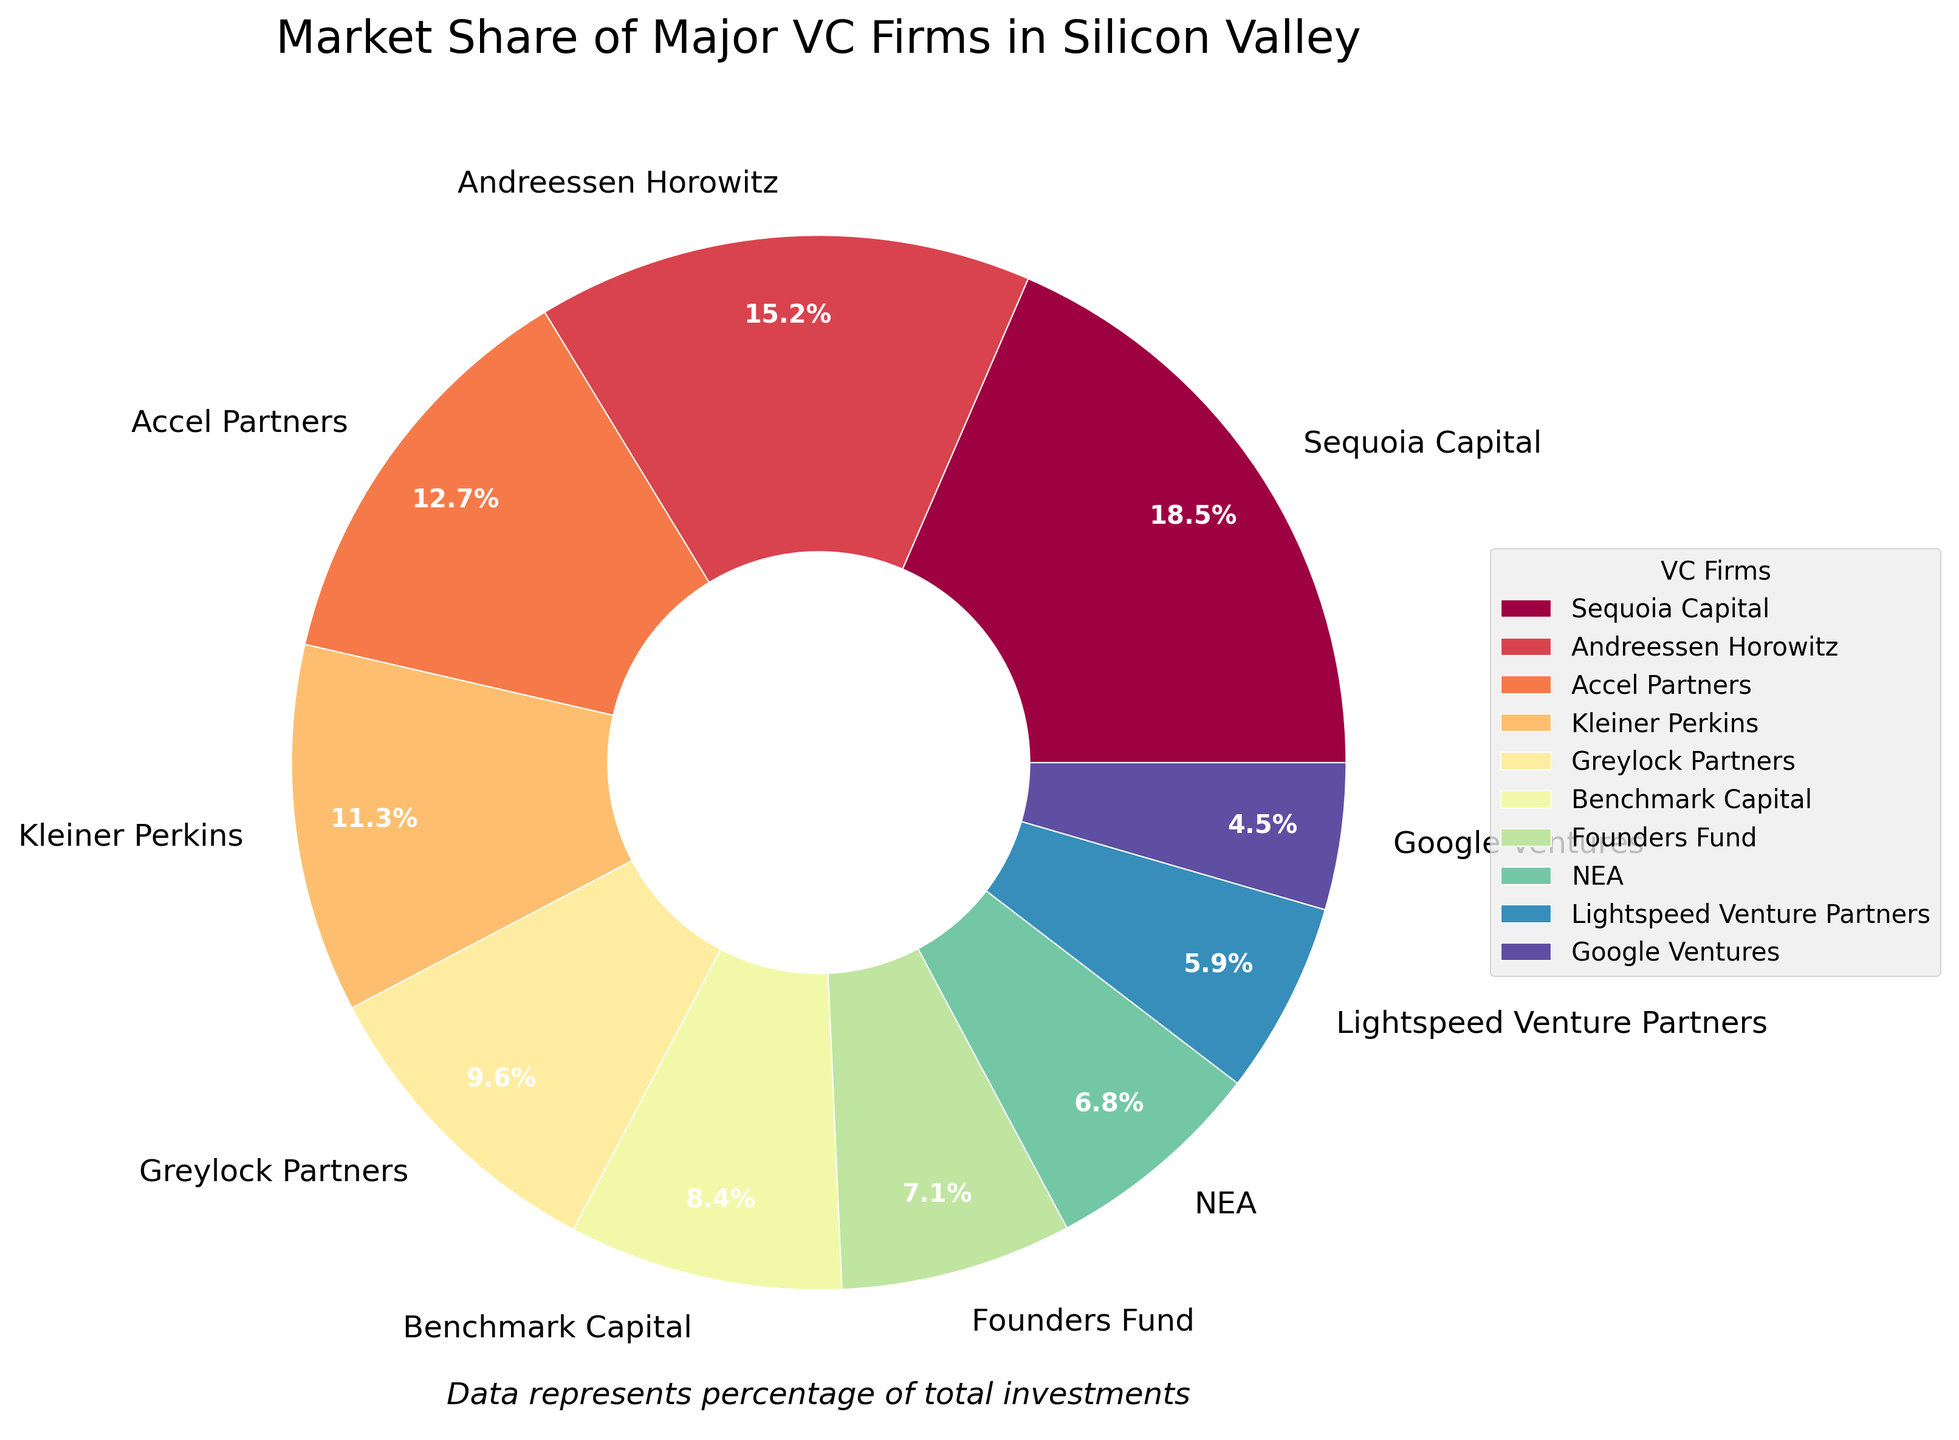What's the largest market share among the venture capital firms? Look at the figure and identify the firm with the largest section in the pie chart. The largest segment is labeled "Sequoia Capital" with 18.5%.
Answer: Sequoia Capital Which two firms have a combined market share of more than 30%? Look at the sizes and labels of the different sections. Sequoia Capital has 18.5% and Andreessen Horowitz has 15.2%. Adding these two gives 33.7%, which is over 30%.
Answer: Sequoia Capital and Andreessen Horowitz How does the market share of Lightspeed Venture Partners compare to NEA? Observe the segments labeled for Lightspeed Venture Partners and NEA. Lightspeed Venture Partners has a market share of 5.9%, and NEA has a market share of 6.8%. 5.9% is less than 6.8%.
Answer: Lightspeed Venture Partners has a smaller share than NEA What is the total market share of firms with individual shares less than 10%? Identify the firms with market shares less than 10%: Greylock Partners (9.6%), Benchmark Capital (8.4%), Founders Fund (7.1%), NEA (6.8%), Lightspeed Venture Partners (5.9%), and Google Ventures (4.5%). Sum these values: 9.6 + 8.4 + 7.1 + 6.8 + 5.9 + 4.5 = 42.3%.
Answer: 42.3% What percentage of the market share is held by Accel Partners and Kleiner Perkins combined? Find the segments labeled Accel Partners (12.7%) and Kleiner Perkins (11.3%), and add their market shares: 12.7 + 11.3 = 24.0%.
Answer: 24.0% Which firm has the smallest market share and what is its color? Look at the smallest segment in the pie chart. It is labeled "Google Ventures" with 4.5% and is colored in a shade from the custom color palette.
Answer: Google Ventures, the specific color depends on the palette used Which firms have a market share between 5% and 10%? Identify the segments falling within the range. Greylock Partners (9.6%), Benchmark Capital (8.4%), Founders Fund (7.1%), NEA (6.8%), and Lightspeed Venture Partners (5.9%).
Answer: Greylock Partners, Benchmark Capital, Founders Fund, NEA, Lightspeed Venture Partners 